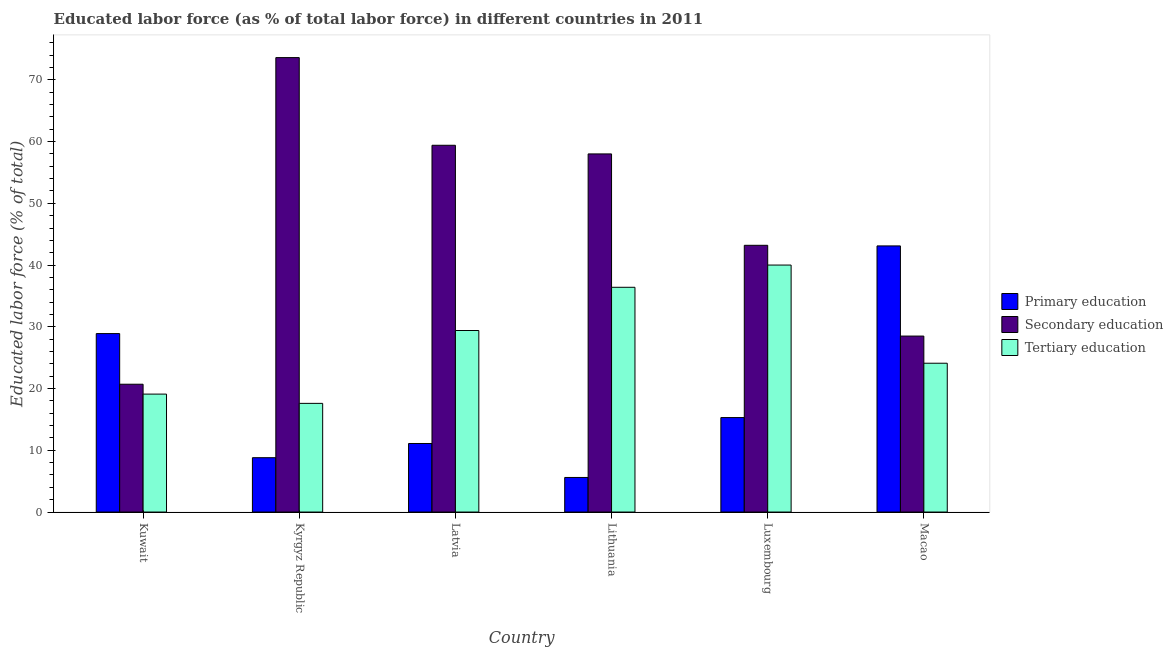Are the number of bars per tick equal to the number of legend labels?
Give a very brief answer. Yes. Are the number of bars on each tick of the X-axis equal?
Offer a very short reply. Yes. How many bars are there on the 6th tick from the left?
Provide a short and direct response. 3. How many bars are there on the 1st tick from the right?
Your response must be concise. 3. What is the label of the 3rd group of bars from the left?
Provide a succinct answer. Latvia. What is the percentage of labor force who received primary education in Kyrgyz Republic?
Offer a terse response. 8.8. Across all countries, what is the maximum percentage of labor force who received tertiary education?
Ensure brevity in your answer.  40. Across all countries, what is the minimum percentage of labor force who received primary education?
Offer a terse response. 5.6. In which country was the percentage of labor force who received secondary education maximum?
Offer a terse response. Kyrgyz Republic. In which country was the percentage of labor force who received secondary education minimum?
Your answer should be very brief. Kuwait. What is the total percentage of labor force who received tertiary education in the graph?
Your response must be concise. 166.6. What is the difference between the percentage of labor force who received secondary education in Kyrgyz Republic and that in Macao?
Give a very brief answer. 45.1. What is the difference between the percentage of labor force who received tertiary education in Luxembourg and the percentage of labor force who received primary education in Kuwait?
Your answer should be very brief. 11.1. What is the average percentage of labor force who received primary education per country?
Make the answer very short. 18.8. What is the difference between the percentage of labor force who received primary education and percentage of labor force who received tertiary education in Kuwait?
Provide a succinct answer. 9.8. In how many countries, is the percentage of labor force who received tertiary education greater than 24 %?
Your answer should be very brief. 4. What is the ratio of the percentage of labor force who received secondary education in Kuwait to that in Kyrgyz Republic?
Offer a very short reply. 0.28. Is the difference between the percentage of labor force who received primary education in Kuwait and Luxembourg greater than the difference between the percentage of labor force who received tertiary education in Kuwait and Luxembourg?
Provide a short and direct response. Yes. What is the difference between the highest and the second highest percentage of labor force who received tertiary education?
Your answer should be very brief. 3.6. What is the difference between the highest and the lowest percentage of labor force who received tertiary education?
Your answer should be compact. 22.4. What does the 1st bar from the left in Luxembourg represents?
Provide a succinct answer. Primary education. What does the 2nd bar from the right in Lithuania represents?
Make the answer very short. Secondary education. Is it the case that in every country, the sum of the percentage of labor force who received primary education and percentage of labor force who received secondary education is greater than the percentage of labor force who received tertiary education?
Offer a terse response. Yes. How many bars are there?
Your response must be concise. 18. Are all the bars in the graph horizontal?
Keep it short and to the point. No. What is the difference between two consecutive major ticks on the Y-axis?
Your answer should be very brief. 10. Does the graph contain any zero values?
Provide a short and direct response. No. Does the graph contain grids?
Provide a short and direct response. No. How many legend labels are there?
Your response must be concise. 3. How are the legend labels stacked?
Your response must be concise. Vertical. What is the title of the graph?
Offer a terse response. Educated labor force (as % of total labor force) in different countries in 2011. What is the label or title of the X-axis?
Offer a very short reply. Country. What is the label or title of the Y-axis?
Your response must be concise. Educated labor force (% of total). What is the Educated labor force (% of total) of Primary education in Kuwait?
Provide a short and direct response. 28.9. What is the Educated labor force (% of total) in Secondary education in Kuwait?
Your answer should be compact. 20.7. What is the Educated labor force (% of total) in Tertiary education in Kuwait?
Give a very brief answer. 19.1. What is the Educated labor force (% of total) in Primary education in Kyrgyz Republic?
Keep it short and to the point. 8.8. What is the Educated labor force (% of total) in Secondary education in Kyrgyz Republic?
Your answer should be compact. 73.6. What is the Educated labor force (% of total) of Tertiary education in Kyrgyz Republic?
Offer a very short reply. 17.6. What is the Educated labor force (% of total) in Primary education in Latvia?
Your answer should be compact. 11.1. What is the Educated labor force (% of total) of Secondary education in Latvia?
Your answer should be compact. 59.4. What is the Educated labor force (% of total) of Tertiary education in Latvia?
Your answer should be very brief. 29.4. What is the Educated labor force (% of total) of Primary education in Lithuania?
Keep it short and to the point. 5.6. What is the Educated labor force (% of total) of Tertiary education in Lithuania?
Your answer should be compact. 36.4. What is the Educated labor force (% of total) in Primary education in Luxembourg?
Your answer should be compact. 15.3. What is the Educated labor force (% of total) of Secondary education in Luxembourg?
Keep it short and to the point. 43.2. What is the Educated labor force (% of total) of Primary education in Macao?
Keep it short and to the point. 43.1. What is the Educated labor force (% of total) of Secondary education in Macao?
Your response must be concise. 28.5. What is the Educated labor force (% of total) in Tertiary education in Macao?
Offer a terse response. 24.1. Across all countries, what is the maximum Educated labor force (% of total) of Primary education?
Ensure brevity in your answer.  43.1. Across all countries, what is the maximum Educated labor force (% of total) of Secondary education?
Give a very brief answer. 73.6. Across all countries, what is the maximum Educated labor force (% of total) in Tertiary education?
Offer a very short reply. 40. Across all countries, what is the minimum Educated labor force (% of total) in Primary education?
Offer a very short reply. 5.6. Across all countries, what is the minimum Educated labor force (% of total) of Secondary education?
Your answer should be compact. 20.7. Across all countries, what is the minimum Educated labor force (% of total) of Tertiary education?
Give a very brief answer. 17.6. What is the total Educated labor force (% of total) of Primary education in the graph?
Ensure brevity in your answer.  112.8. What is the total Educated labor force (% of total) in Secondary education in the graph?
Give a very brief answer. 283.4. What is the total Educated labor force (% of total) of Tertiary education in the graph?
Your answer should be very brief. 166.6. What is the difference between the Educated labor force (% of total) of Primary education in Kuwait and that in Kyrgyz Republic?
Your answer should be very brief. 20.1. What is the difference between the Educated labor force (% of total) in Secondary education in Kuwait and that in Kyrgyz Republic?
Give a very brief answer. -52.9. What is the difference between the Educated labor force (% of total) of Tertiary education in Kuwait and that in Kyrgyz Republic?
Offer a terse response. 1.5. What is the difference between the Educated labor force (% of total) of Secondary education in Kuwait and that in Latvia?
Offer a very short reply. -38.7. What is the difference between the Educated labor force (% of total) of Tertiary education in Kuwait and that in Latvia?
Provide a succinct answer. -10.3. What is the difference between the Educated labor force (% of total) in Primary education in Kuwait and that in Lithuania?
Provide a short and direct response. 23.3. What is the difference between the Educated labor force (% of total) of Secondary education in Kuwait and that in Lithuania?
Your response must be concise. -37.3. What is the difference between the Educated labor force (% of total) of Tertiary education in Kuwait and that in Lithuania?
Your answer should be compact. -17.3. What is the difference between the Educated labor force (% of total) in Secondary education in Kuwait and that in Luxembourg?
Provide a succinct answer. -22.5. What is the difference between the Educated labor force (% of total) of Tertiary education in Kuwait and that in Luxembourg?
Offer a very short reply. -20.9. What is the difference between the Educated labor force (% of total) in Primary education in Kuwait and that in Macao?
Provide a short and direct response. -14.2. What is the difference between the Educated labor force (% of total) of Tertiary education in Kuwait and that in Macao?
Your answer should be compact. -5. What is the difference between the Educated labor force (% of total) of Primary education in Kyrgyz Republic and that in Latvia?
Your answer should be compact. -2.3. What is the difference between the Educated labor force (% of total) of Secondary education in Kyrgyz Republic and that in Latvia?
Your response must be concise. 14.2. What is the difference between the Educated labor force (% of total) of Tertiary education in Kyrgyz Republic and that in Latvia?
Offer a very short reply. -11.8. What is the difference between the Educated labor force (% of total) in Primary education in Kyrgyz Republic and that in Lithuania?
Your response must be concise. 3.2. What is the difference between the Educated labor force (% of total) of Tertiary education in Kyrgyz Republic and that in Lithuania?
Provide a succinct answer. -18.8. What is the difference between the Educated labor force (% of total) of Secondary education in Kyrgyz Republic and that in Luxembourg?
Keep it short and to the point. 30.4. What is the difference between the Educated labor force (% of total) in Tertiary education in Kyrgyz Republic and that in Luxembourg?
Offer a terse response. -22.4. What is the difference between the Educated labor force (% of total) of Primary education in Kyrgyz Republic and that in Macao?
Your answer should be very brief. -34.3. What is the difference between the Educated labor force (% of total) of Secondary education in Kyrgyz Republic and that in Macao?
Provide a succinct answer. 45.1. What is the difference between the Educated labor force (% of total) in Primary education in Latvia and that in Lithuania?
Your answer should be very brief. 5.5. What is the difference between the Educated labor force (% of total) in Tertiary education in Latvia and that in Lithuania?
Give a very brief answer. -7. What is the difference between the Educated labor force (% of total) in Primary education in Latvia and that in Luxembourg?
Give a very brief answer. -4.2. What is the difference between the Educated labor force (% of total) of Secondary education in Latvia and that in Luxembourg?
Provide a short and direct response. 16.2. What is the difference between the Educated labor force (% of total) of Tertiary education in Latvia and that in Luxembourg?
Give a very brief answer. -10.6. What is the difference between the Educated labor force (% of total) of Primary education in Latvia and that in Macao?
Provide a short and direct response. -32. What is the difference between the Educated labor force (% of total) of Secondary education in Latvia and that in Macao?
Ensure brevity in your answer.  30.9. What is the difference between the Educated labor force (% of total) of Tertiary education in Latvia and that in Macao?
Your answer should be compact. 5.3. What is the difference between the Educated labor force (% of total) in Secondary education in Lithuania and that in Luxembourg?
Offer a terse response. 14.8. What is the difference between the Educated labor force (% of total) of Tertiary education in Lithuania and that in Luxembourg?
Give a very brief answer. -3.6. What is the difference between the Educated labor force (% of total) of Primary education in Lithuania and that in Macao?
Your answer should be very brief. -37.5. What is the difference between the Educated labor force (% of total) of Secondary education in Lithuania and that in Macao?
Your answer should be very brief. 29.5. What is the difference between the Educated labor force (% of total) in Tertiary education in Lithuania and that in Macao?
Give a very brief answer. 12.3. What is the difference between the Educated labor force (% of total) of Primary education in Luxembourg and that in Macao?
Offer a terse response. -27.8. What is the difference between the Educated labor force (% of total) in Secondary education in Luxembourg and that in Macao?
Provide a succinct answer. 14.7. What is the difference between the Educated labor force (% of total) of Primary education in Kuwait and the Educated labor force (% of total) of Secondary education in Kyrgyz Republic?
Ensure brevity in your answer.  -44.7. What is the difference between the Educated labor force (% of total) in Primary education in Kuwait and the Educated labor force (% of total) in Tertiary education in Kyrgyz Republic?
Provide a short and direct response. 11.3. What is the difference between the Educated labor force (% of total) of Secondary education in Kuwait and the Educated labor force (% of total) of Tertiary education in Kyrgyz Republic?
Make the answer very short. 3.1. What is the difference between the Educated labor force (% of total) in Primary education in Kuwait and the Educated labor force (% of total) in Secondary education in Latvia?
Make the answer very short. -30.5. What is the difference between the Educated labor force (% of total) in Primary education in Kuwait and the Educated labor force (% of total) in Secondary education in Lithuania?
Make the answer very short. -29.1. What is the difference between the Educated labor force (% of total) in Secondary education in Kuwait and the Educated labor force (% of total) in Tertiary education in Lithuania?
Provide a succinct answer. -15.7. What is the difference between the Educated labor force (% of total) of Primary education in Kuwait and the Educated labor force (% of total) of Secondary education in Luxembourg?
Offer a very short reply. -14.3. What is the difference between the Educated labor force (% of total) of Secondary education in Kuwait and the Educated labor force (% of total) of Tertiary education in Luxembourg?
Offer a very short reply. -19.3. What is the difference between the Educated labor force (% of total) of Secondary education in Kuwait and the Educated labor force (% of total) of Tertiary education in Macao?
Make the answer very short. -3.4. What is the difference between the Educated labor force (% of total) of Primary education in Kyrgyz Republic and the Educated labor force (% of total) of Secondary education in Latvia?
Offer a very short reply. -50.6. What is the difference between the Educated labor force (% of total) of Primary education in Kyrgyz Republic and the Educated labor force (% of total) of Tertiary education in Latvia?
Provide a succinct answer. -20.6. What is the difference between the Educated labor force (% of total) in Secondary education in Kyrgyz Republic and the Educated labor force (% of total) in Tertiary education in Latvia?
Give a very brief answer. 44.2. What is the difference between the Educated labor force (% of total) in Primary education in Kyrgyz Republic and the Educated labor force (% of total) in Secondary education in Lithuania?
Provide a short and direct response. -49.2. What is the difference between the Educated labor force (% of total) in Primary education in Kyrgyz Republic and the Educated labor force (% of total) in Tertiary education in Lithuania?
Provide a short and direct response. -27.6. What is the difference between the Educated labor force (% of total) in Secondary education in Kyrgyz Republic and the Educated labor force (% of total) in Tertiary education in Lithuania?
Your answer should be compact. 37.2. What is the difference between the Educated labor force (% of total) in Primary education in Kyrgyz Republic and the Educated labor force (% of total) in Secondary education in Luxembourg?
Keep it short and to the point. -34.4. What is the difference between the Educated labor force (% of total) of Primary education in Kyrgyz Republic and the Educated labor force (% of total) of Tertiary education in Luxembourg?
Make the answer very short. -31.2. What is the difference between the Educated labor force (% of total) of Secondary education in Kyrgyz Republic and the Educated labor force (% of total) of Tertiary education in Luxembourg?
Provide a short and direct response. 33.6. What is the difference between the Educated labor force (% of total) of Primary education in Kyrgyz Republic and the Educated labor force (% of total) of Secondary education in Macao?
Your answer should be very brief. -19.7. What is the difference between the Educated labor force (% of total) in Primary education in Kyrgyz Republic and the Educated labor force (% of total) in Tertiary education in Macao?
Make the answer very short. -15.3. What is the difference between the Educated labor force (% of total) in Secondary education in Kyrgyz Republic and the Educated labor force (% of total) in Tertiary education in Macao?
Ensure brevity in your answer.  49.5. What is the difference between the Educated labor force (% of total) in Primary education in Latvia and the Educated labor force (% of total) in Secondary education in Lithuania?
Your response must be concise. -46.9. What is the difference between the Educated labor force (% of total) in Primary education in Latvia and the Educated labor force (% of total) in Tertiary education in Lithuania?
Your answer should be very brief. -25.3. What is the difference between the Educated labor force (% of total) of Secondary education in Latvia and the Educated labor force (% of total) of Tertiary education in Lithuania?
Provide a succinct answer. 23. What is the difference between the Educated labor force (% of total) in Primary education in Latvia and the Educated labor force (% of total) in Secondary education in Luxembourg?
Provide a succinct answer. -32.1. What is the difference between the Educated labor force (% of total) in Primary education in Latvia and the Educated labor force (% of total) in Tertiary education in Luxembourg?
Your answer should be very brief. -28.9. What is the difference between the Educated labor force (% of total) of Secondary education in Latvia and the Educated labor force (% of total) of Tertiary education in Luxembourg?
Your answer should be very brief. 19.4. What is the difference between the Educated labor force (% of total) of Primary education in Latvia and the Educated labor force (% of total) of Secondary education in Macao?
Offer a very short reply. -17.4. What is the difference between the Educated labor force (% of total) of Secondary education in Latvia and the Educated labor force (% of total) of Tertiary education in Macao?
Keep it short and to the point. 35.3. What is the difference between the Educated labor force (% of total) of Primary education in Lithuania and the Educated labor force (% of total) of Secondary education in Luxembourg?
Your response must be concise. -37.6. What is the difference between the Educated labor force (% of total) of Primary education in Lithuania and the Educated labor force (% of total) of Tertiary education in Luxembourg?
Provide a succinct answer. -34.4. What is the difference between the Educated labor force (% of total) in Primary education in Lithuania and the Educated labor force (% of total) in Secondary education in Macao?
Provide a short and direct response. -22.9. What is the difference between the Educated labor force (% of total) of Primary education in Lithuania and the Educated labor force (% of total) of Tertiary education in Macao?
Provide a succinct answer. -18.5. What is the difference between the Educated labor force (% of total) in Secondary education in Lithuania and the Educated labor force (% of total) in Tertiary education in Macao?
Give a very brief answer. 33.9. What is the average Educated labor force (% of total) in Secondary education per country?
Give a very brief answer. 47.23. What is the average Educated labor force (% of total) in Tertiary education per country?
Provide a short and direct response. 27.77. What is the difference between the Educated labor force (% of total) of Primary education and Educated labor force (% of total) of Secondary education in Kyrgyz Republic?
Your response must be concise. -64.8. What is the difference between the Educated labor force (% of total) in Secondary education and Educated labor force (% of total) in Tertiary education in Kyrgyz Republic?
Your response must be concise. 56. What is the difference between the Educated labor force (% of total) in Primary education and Educated labor force (% of total) in Secondary education in Latvia?
Offer a very short reply. -48.3. What is the difference between the Educated labor force (% of total) of Primary education and Educated labor force (% of total) of Tertiary education in Latvia?
Make the answer very short. -18.3. What is the difference between the Educated labor force (% of total) of Secondary education and Educated labor force (% of total) of Tertiary education in Latvia?
Offer a terse response. 30. What is the difference between the Educated labor force (% of total) in Primary education and Educated labor force (% of total) in Secondary education in Lithuania?
Give a very brief answer. -52.4. What is the difference between the Educated labor force (% of total) of Primary education and Educated labor force (% of total) of Tertiary education in Lithuania?
Give a very brief answer. -30.8. What is the difference between the Educated labor force (% of total) in Secondary education and Educated labor force (% of total) in Tertiary education in Lithuania?
Your answer should be compact. 21.6. What is the difference between the Educated labor force (% of total) in Primary education and Educated labor force (% of total) in Secondary education in Luxembourg?
Your response must be concise. -27.9. What is the difference between the Educated labor force (% of total) of Primary education and Educated labor force (% of total) of Tertiary education in Luxembourg?
Your response must be concise. -24.7. What is the difference between the Educated labor force (% of total) of Primary education and Educated labor force (% of total) of Tertiary education in Macao?
Keep it short and to the point. 19. What is the difference between the Educated labor force (% of total) of Secondary education and Educated labor force (% of total) of Tertiary education in Macao?
Make the answer very short. 4.4. What is the ratio of the Educated labor force (% of total) in Primary education in Kuwait to that in Kyrgyz Republic?
Your answer should be very brief. 3.28. What is the ratio of the Educated labor force (% of total) in Secondary education in Kuwait to that in Kyrgyz Republic?
Provide a succinct answer. 0.28. What is the ratio of the Educated labor force (% of total) in Tertiary education in Kuwait to that in Kyrgyz Republic?
Your response must be concise. 1.09. What is the ratio of the Educated labor force (% of total) in Primary education in Kuwait to that in Latvia?
Provide a short and direct response. 2.6. What is the ratio of the Educated labor force (% of total) in Secondary education in Kuwait to that in Latvia?
Your response must be concise. 0.35. What is the ratio of the Educated labor force (% of total) of Tertiary education in Kuwait to that in Latvia?
Make the answer very short. 0.65. What is the ratio of the Educated labor force (% of total) of Primary education in Kuwait to that in Lithuania?
Your answer should be compact. 5.16. What is the ratio of the Educated labor force (% of total) in Secondary education in Kuwait to that in Lithuania?
Ensure brevity in your answer.  0.36. What is the ratio of the Educated labor force (% of total) of Tertiary education in Kuwait to that in Lithuania?
Keep it short and to the point. 0.52. What is the ratio of the Educated labor force (% of total) of Primary education in Kuwait to that in Luxembourg?
Offer a very short reply. 1.89. What is the ratio of the Educated labor force (% of total) in Secondary education in Kuwait to that in Luxembourg?
Ensure brevity in your answer.  0.48. What is the ratio of the Educated labor force (% of total) of Tertiary education in Kuwait to that in Luxembourg?
Give a very brief answer. 0.48. What is the ratio of the Educated labor force (% of total) of Primary education in Kuwait to that in Macao?
Provide a succinct answer. 0.67. What is the ratio of the Educated labor force (% of total) in Secondary education in Kuwait to that in Macao?
Your response must be concise. 0.73. What is the ratio of the Educated labor force (% of total) in Tertiary education in Kuwait to that in Macao?
Your answer should be compact. 0.79. What is the ratio of the Educated labor force (% of total) in Primary education in Kyrgyz Republic to that in Latvia?
Offer a very short reply. 0.79. What is the ratio of the Educated labor force (% of total) in Secondary education in Kyrgyz Republic to that in Latvia?
Your response must be concise. 1.24. What is the ratio of the Educated labor force (% of total) in Tertiary education in Kyrgyz Republic to that in Latvia?
Your response must be concise. 0.6. What is the ratio of the Educated labor force (% of total) in Primary education in Kyrgyz Republic to that in Lithuania?
Provide a short and direct response. 1.57. What is the ratio of the Educated labor force (% of total) of Secondary education in Kyrgyz Republic to that in Lithuania?
Provide a succinct answer. 1.27. What is the ratio of the Educated labor force (% of total) in Tertiary education in Kyrgyz Republic to that in Lithuania?
Offer a very short reply. 0.48. What is the ratio of the Educated labor force (% of total) in Primary education in Kyrgyz Republic to that in Luxembourg?
Give a very brief answer. 0.58. What is the ratio of the Educated labor force (% of total) of Secondary education in Kyrgyz Republic to that in Luxembourg?
Provide a succinct answer. 1.7. What is the ratio of the Educated labor force (% of total) in Tertiary education in Kyrgyz Republic to that in Luxembourg?
Your answer should be compact. 0.44. What is the ratio of the Educated labor force (% of total) of Primary education in Kyrgyz Republic to that in Macao?
Make the answer very short. 0.2. What is the ratio of the Educated labor force (% of total) of Secondary education in Kyrgyz Republic to that in Macao?
Make the answer very short. 2.58. What is the ratio of the Educated labor force (% of total) of Tertiary education in Kyrgyz Republic to that in Macao?
Give a very brief answer. 0.73. What is the ratio of the Educated labor force (% of total) of Primary education in Latvia to that in Lithuania?
Give a very brief answer. 1.98. What is the ratio of the Educated labor force (% of total) of Secondary education in Latvia to that in Lithuania?
Your answer should be compact. 1.02. What is the ratio of the Educated labor force (% of total) in Tertiary education in Latvia to that in Lithuania?
Your answer should be compact. 0.81. What is the ratio of the Educated labor force (% of total) of Primary education in Latvia to that in Luxembourg?
Provide a short and direct response. 0.73. What is the ratio of the Educated labor force (% of total) of Secondary education in Latvia to that in Luxembourg?
Provide a short and direct response. 1.38. What is the ratio of the Educated labor force (% of total) in Tertiary education in Latvia to that in Luxembourg?
Provide a short and direct response. 0.73. What is the ratio of the Educated labor force (% of total) of Primary education in Latvia to that in Macao?
Give a very brief answer. 0.26. What is the ratio of the Educated labor force (% of total) in Secondary education in Latvia to that in Macao?
Your response must be concise. 2.08. What is the ratio of the Educated labor force (% of total) in Tertiary education in Latvia to that in Macao?
Provide a short and direct response. 1.22. What is the ratio of the Educated labor force (% of total) of Primary education in Lithuania to that in Luxembourg?
Your answer should be compact. 0.37. What is the ratio of the Educated labor force (% of total) of Secondary education in Lithuania to that in Luxembourg?
Give a very brief answer. 1.34. What is the ratio of the Educated labor force (% of total) in Tertiary education in Lithuania to that in Luxembourg?
Make the answer very short. 0.91. What is the ratio of the Educated labor force (% of total) of Primary education in Lithuania to that in Macao?
Your answer should be compact. 0.13. What is the ratio of the Educated labor force (% of total) in Secondary education in Lithuania to that in Macao?
Offer a terse response. 2.04. What is the ratio of the Educated labor force (% of total) of Tertiary education in Lithuania to that in Macao?
Offer a very short reply. 1.51. What is the ratio of the Educated labor force (% of total) of Primary education in Luxembourg to that in Macao?
Your answer should be compact. 0.35. What is the ratio of the Educated labor force (% of total) of Secondary education in Luxembourg to that in Macao?
Provide a succinct answer. 1.52. What is the ratio of the Educated labor force (% of total) in Tertiary education in Luxembourg to that in Macao?
Keep it short and to the point. 1.66. What is the difference between the highest and the second highest Educated labor force (% of total) in Primary education?
Offer a terse response. 14.2. What is the difference between the highest and the lowest Educated labor force (% of total) of Primary education?
Your answer should be compact. 37.5. What is the difference between the highest and the lowest Educated labor force (% of total) in Secondary education?
Give a very brief answer. 52.9. What is the difference between the highest and the lowest Educated labor force (% of total) of Tertiary education?
Give a very brief answer. 22.4. 